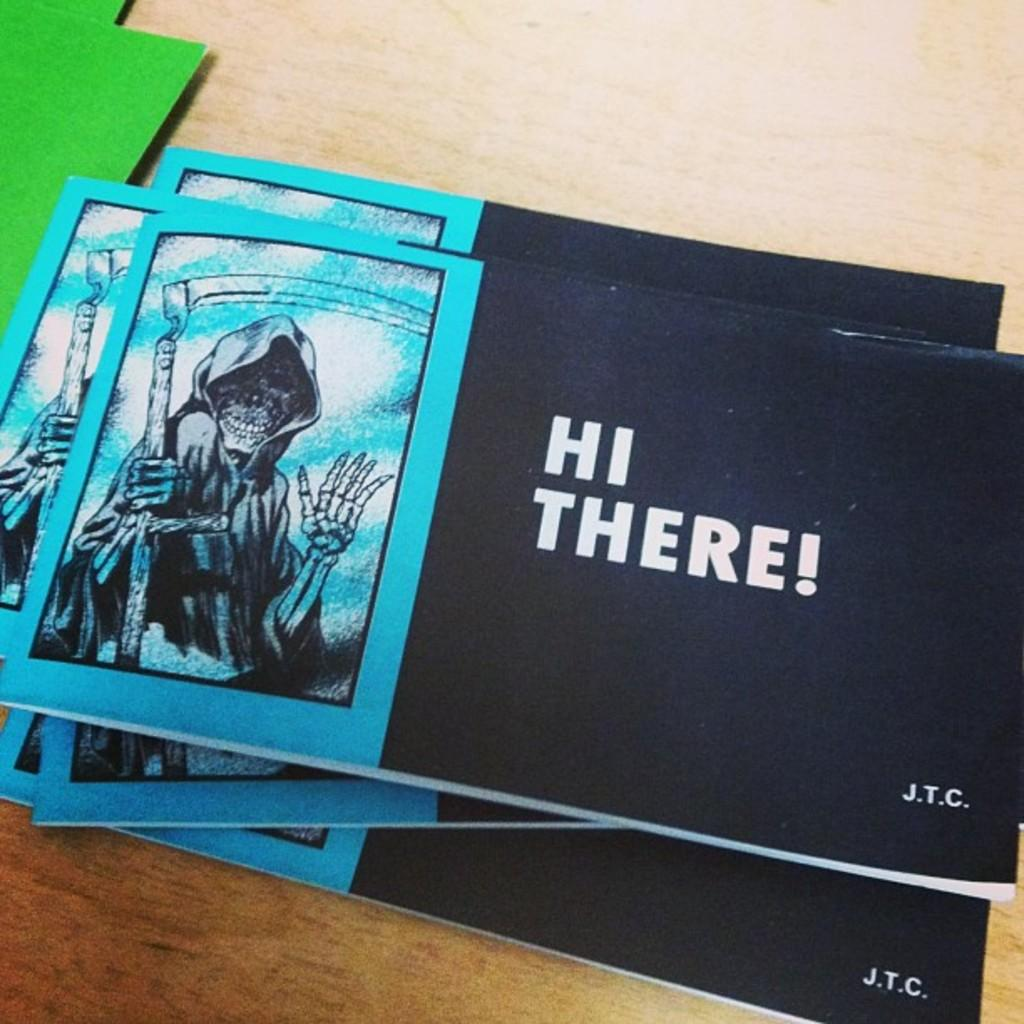<image>
Render a clear and concise summary of the photo. A tract or booklet entitled Hi There! from the company J.T.C. 